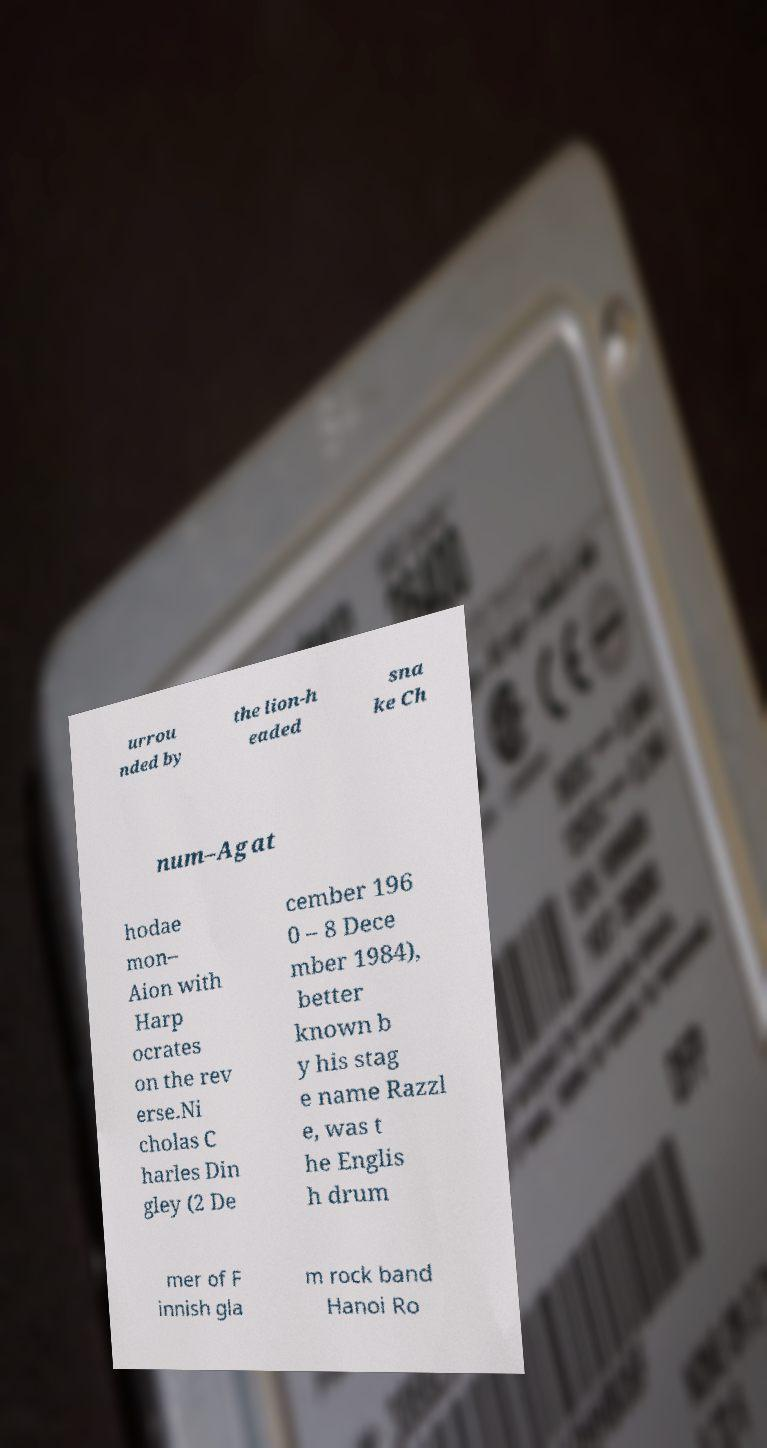I need the written content from this picture converted into text. Can you do that? urrou nded by the lion-h eaded sna ke Ch num–Agat hodae mon– Aion with Harp ocrates on the rev erse.Ni cholas C harles Din gley (2 De cember 196 0 – 8 Dece mber 1984), better known b y his stag e name Razzl e, was t he Englis h drum mer of F innish gla m rock band Hanoi Ro 